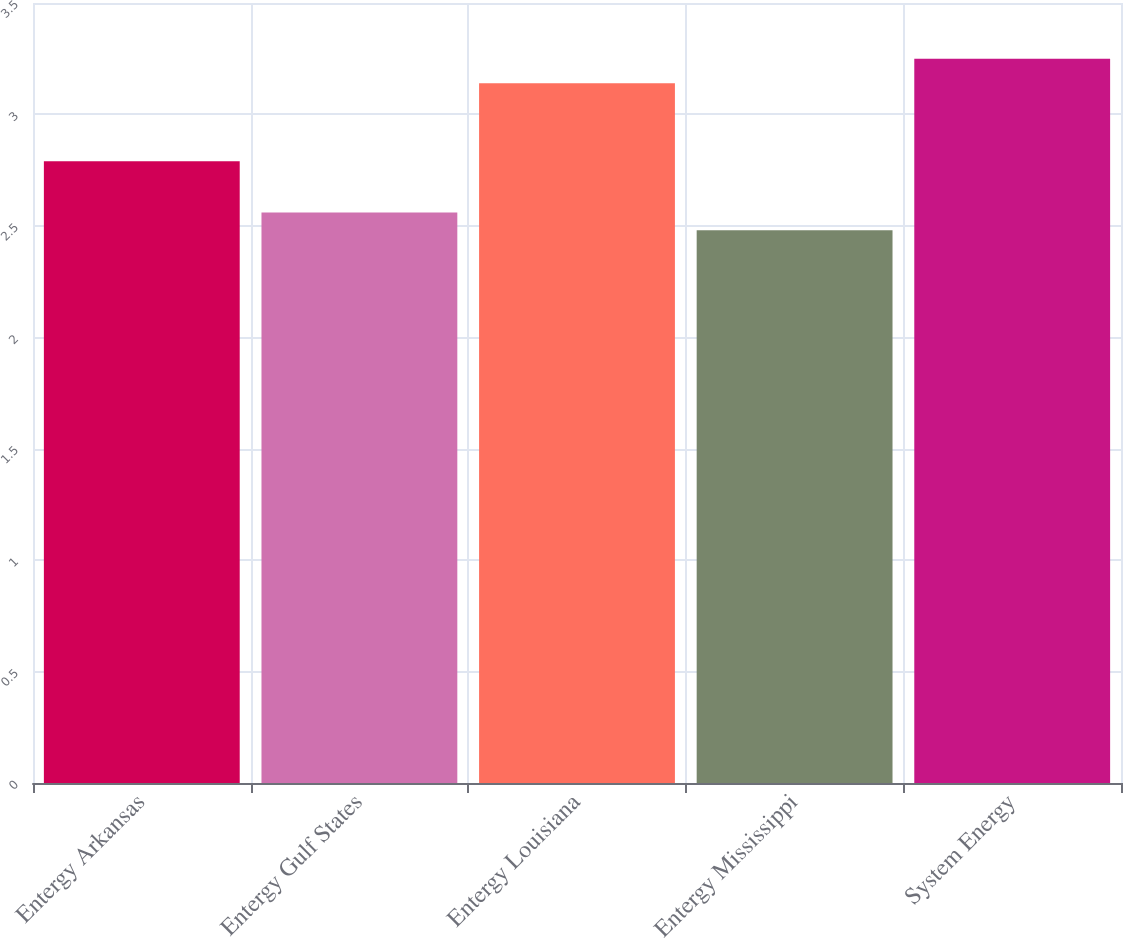Convert chart. <chart><loc_0><loc_0><loc_500><loc_500><bar_chart><fcel>Entergy Arkansas<fcel>Entergy Gulf States<fcel>Entergy Louisiana<fcel>Entergy Mississippi<fcel>System Energy<nl><fcel>2.79<fcel>2.56<fcel>3.14<fcel>2.48<fcel>3.25<nl></chart> 